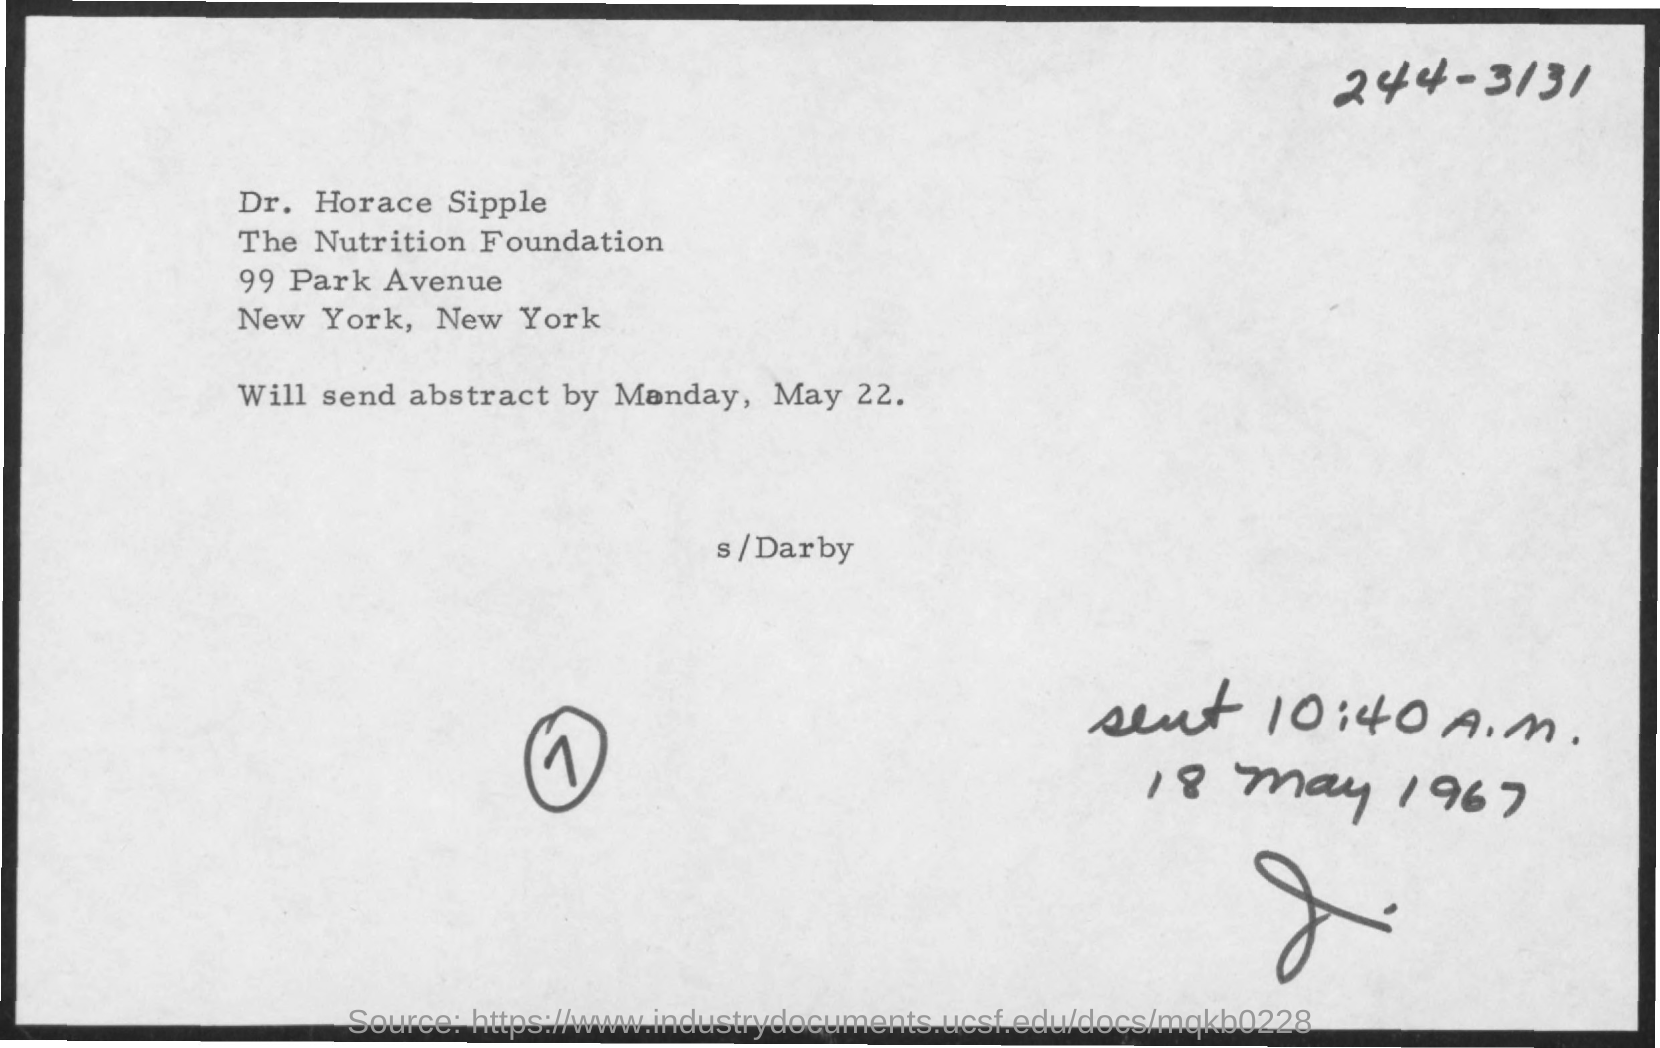List a handful of essential elements in this visual. The sent time mentioned in the document is 10:40 A.M. The abstract will be sent on the date of Monday, May 22. The intended recipient of the message is Dr. Horace Sipple. 